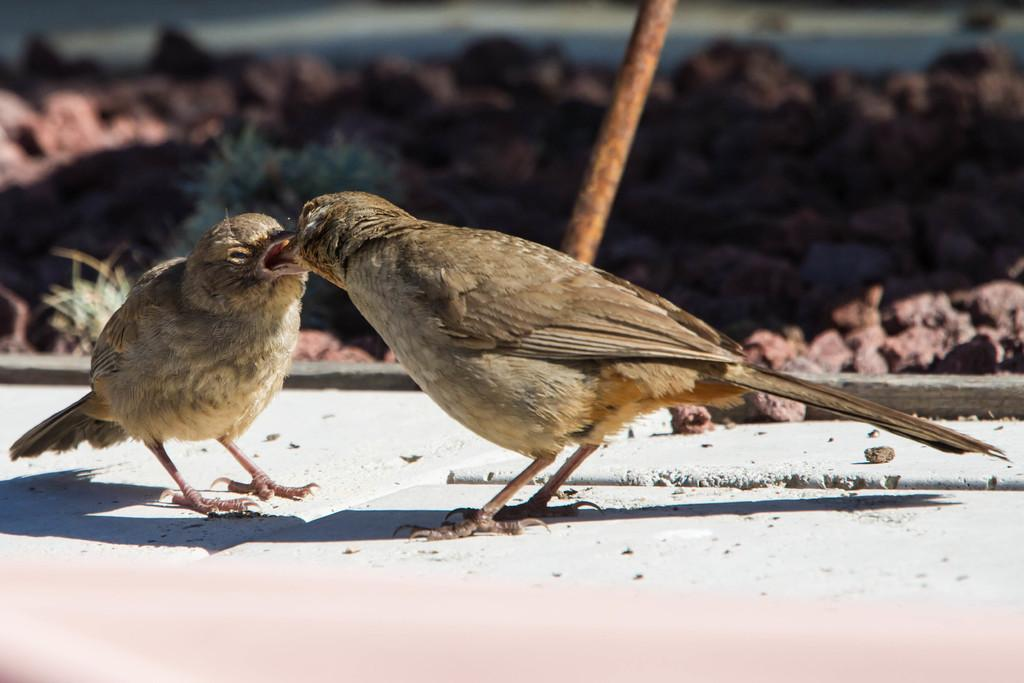How many birds are present in the image? There are 2 birds in the image. What color is the surface where the birds are resting? The birds are on a white color surface. What is the color of the birds? The birds are brown in color. Can you describe the background of the image? There is a brown color thing in the background of the image. What is the profit made by the birds in the image? There is no mention of profit in the image, as it features birds on a surface. What observation can be made about the birds' behavior in the image? The image does not show the birds' behavior, only their position on the white surface. 